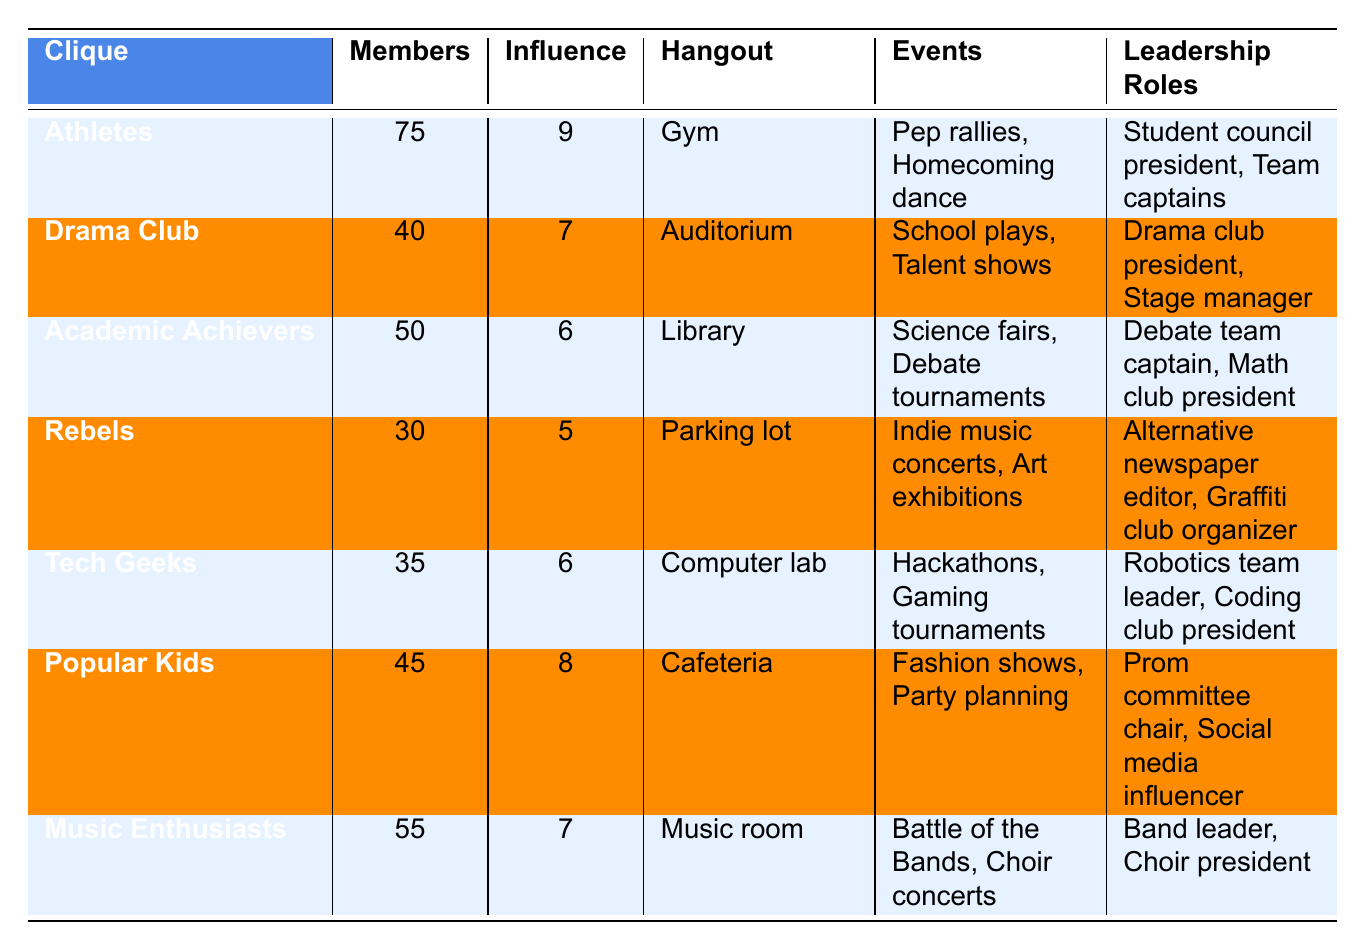What is the primary hangout for the Popular Kids clique? The table directly lists the primary hangout for each clique. For the Popular Kids, it states their primary hangout is the Cafeteria.
Answer: Cafeteria Which clique has the highest influence score? By examining the influence scores listed, we see that the Athletes have the highest score at 9.
Answer: Athletes How many members are there in the Drama Club? The table specifies that the Drama Club has 40 members.
Answer: 40 What is the total number of members in the Academic Achievers and Music Enthusiasts cliques combined? The number of members in the Academic Achievers is 50, and in the Music Enthusiasts, it is 55. Summing these gives 50 + 55 = 105 members.
Answer: 105 Do the Rebels have more influence than the Tech Geeks? The Rebels have an influence score of 5, while the Tech Geeks have an influence score of 6. Since 5 is less than 6, the Rebels do not have more influence.
Answer: No What is the average number of members across all cliques? We add together all the members: 75 + 40 + 50 + 30 + 35 + 45 + 55 = 330. Then we divide by the number of cliques (7) to find the average: 330 / 7 = approximately 47.14.
Answer: 47.14 Which cliques are known for organizing talent-related events? The table shows that the Drama Club organizes school plays and talent shows, while Music Enthusiasts are known for Battle of the Bands and choir concerts. Both are focused on talent-related events.
Answer: Drama Club, Music Enthusiasts How many cliques have an influence score of 7 or higher? The cliques with scores of 7 or higher are Athletes (9), Popular Kids (8), Drama Club (7), and Music Enthusiasts (7). Counting these gives us a total of 4 cliques.
Answer: 4 What events are typically organized by the Tech Geeks? The events listed for the Tech Geeks are Hackathons and Gaming tournaments, as specified in the table.
Answer: Hackathons, Gaming tournaments If you were to compare the leadership roles for the Academic Achievers and the Rebels, which clique has more distinct roles mentioned? The Academic Achievers have 2 distinct leadership roles mentioned (Debate team captain, Math club president), while the Rebels also have 2 (Alternative newspaper editor, Graffiti club organizer). Both have the same number of distinct roles.
Answer: They have the same number 